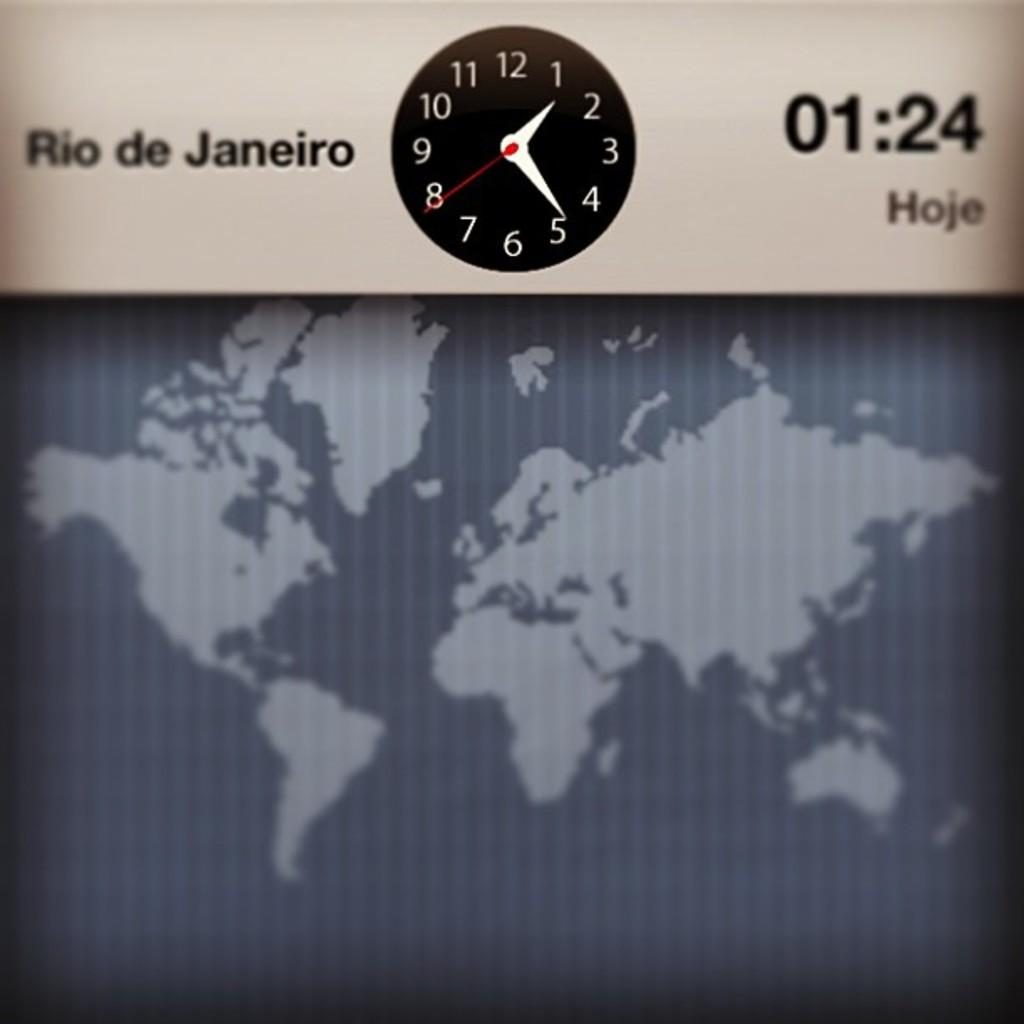<image>
Summarize the visual content of the image. A clock showing the time in Rio de Janeiro. 